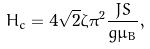Convert formula to latex. <formula><loc_0><loc_0><loc_500><loc_500>H _ { c } = 4 \sqrt { 2 } \zeta \pi ^ { 2 } \frac { J S } { g \mu _ { B } } ,</formula> 